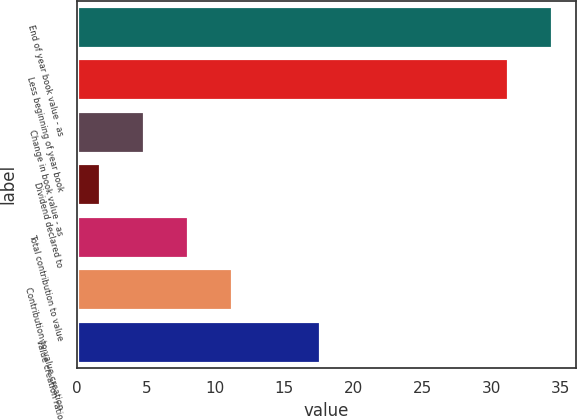Convert chart. <chart><loc_0><loc_0><loc_500><loc_500><bar_chart><fcel>End of year book value - as<fcel>Less beginning of year book<fcel>Change in book value - as<fcel>Dividend declared to<fcel>Total contribution to value<fcel>Contribution to value creation<fcel>Value creation ratio<nl><fcel>34.35<fcel>31.16<fcel>4.81<fcel>1.62<fcel>8<fcel>11.19<fcel>17.57<nl></chart> 